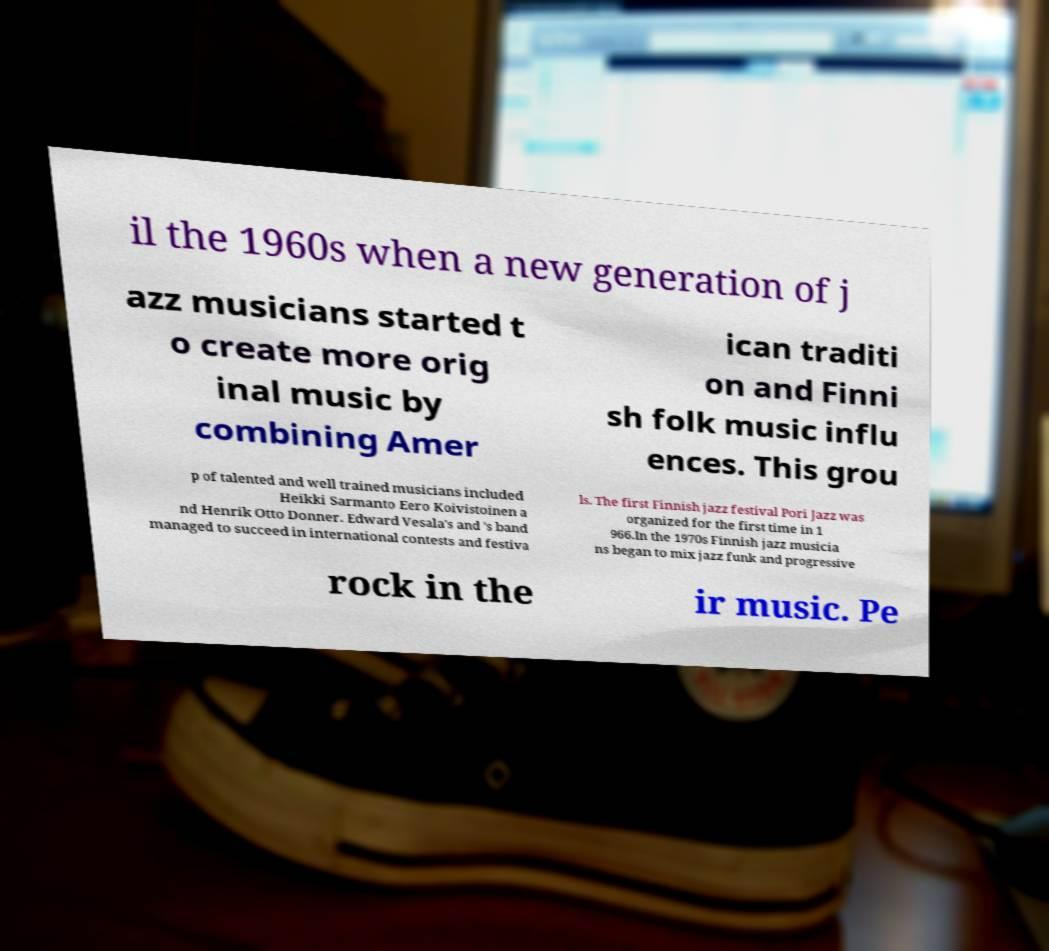Please identify and transcribe the text found in this image. il the 1960s when a new generation of j azz musicians started t o create more orig inal music by combining Amer ican traditi on and Finni sh folk music influ ences. This grou p of talented and well trained musicians included Heikki Sarmanto Eero Koivistoinen a nd Henrik Otto Donner. Edward Vesala's and 's band managed to succeed in international contests and festiva ls. The first Finnish jazz festival Pori Jazz was organized for the first time in 1 966.In the 1970s Finnish jazz musicia ns began to mix jazz funk and progressive rock in the ir music. Pe 